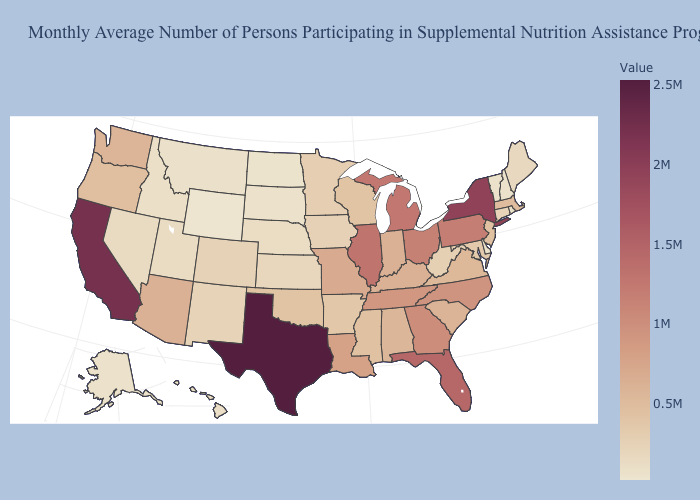Which states have the lowest value in the USA?
Keep it brief. Wyoming. Among the states that border Ohio , which have the lowest value?
Be succinct. West Virginia. Which states have the lowest value in the South?
Be succinct. Delaware. Does Connecticut have the lowest value in the USA?
Be succinct. No. Among the states that border Indiana , does Michigan have the lowest value?
Quick response, please. No. Does Wyoming have the lowest value in the USA?
Write a very short answer. Yes. Does Vermont have the highest value in the Northeast?
Short answer required. No. 